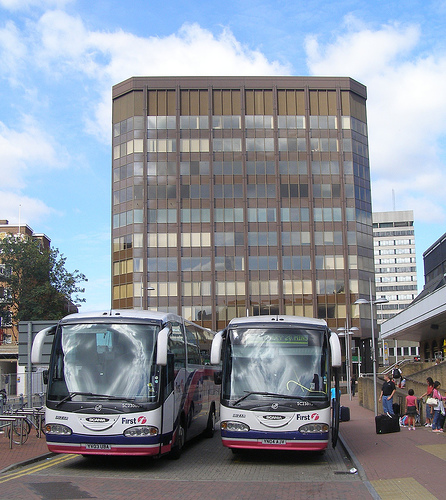How busy does the bus station appear to be in this image? The bus station appears moderately busy with several individuals around the buses, suggesting an active public transport hub. 